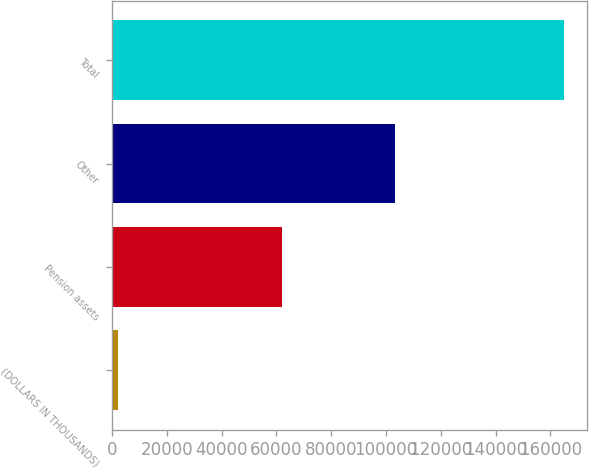<chart> <loc_0><loc_0><loc_500><loc_500><bar_chart><fcel>(DOLLARS IN THOUSANDS)<fcel>Pension assets<fcel>Other<fcel>Total<nl><fcel>2009<fcel>61881<fcel>103284<fcel>165165<nl></chart> 